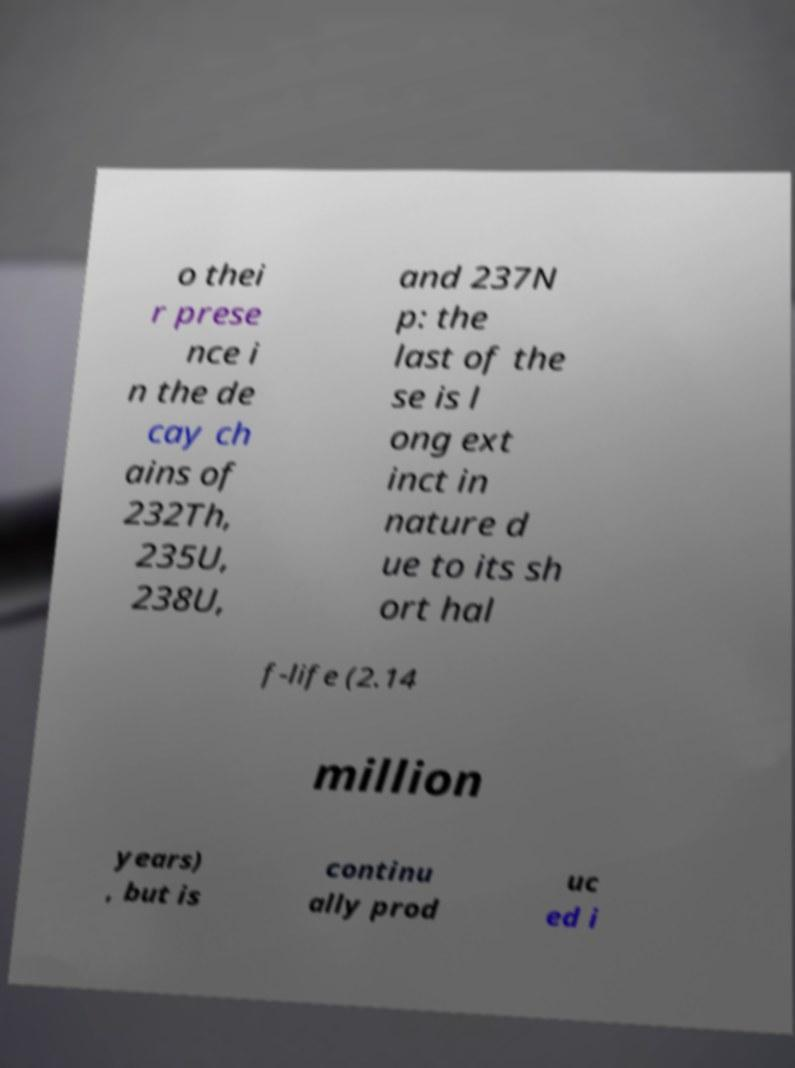Please identify and transcribe the text found in this image. o thei r prese nce i n the de cay ch ains of 232Th, 235U, 238U, and 237N p: the last of the se is l ong ext inct in nature d ue to its sh ort hal f-life (2.14 million years) , but is continu ally prod uc ed i 